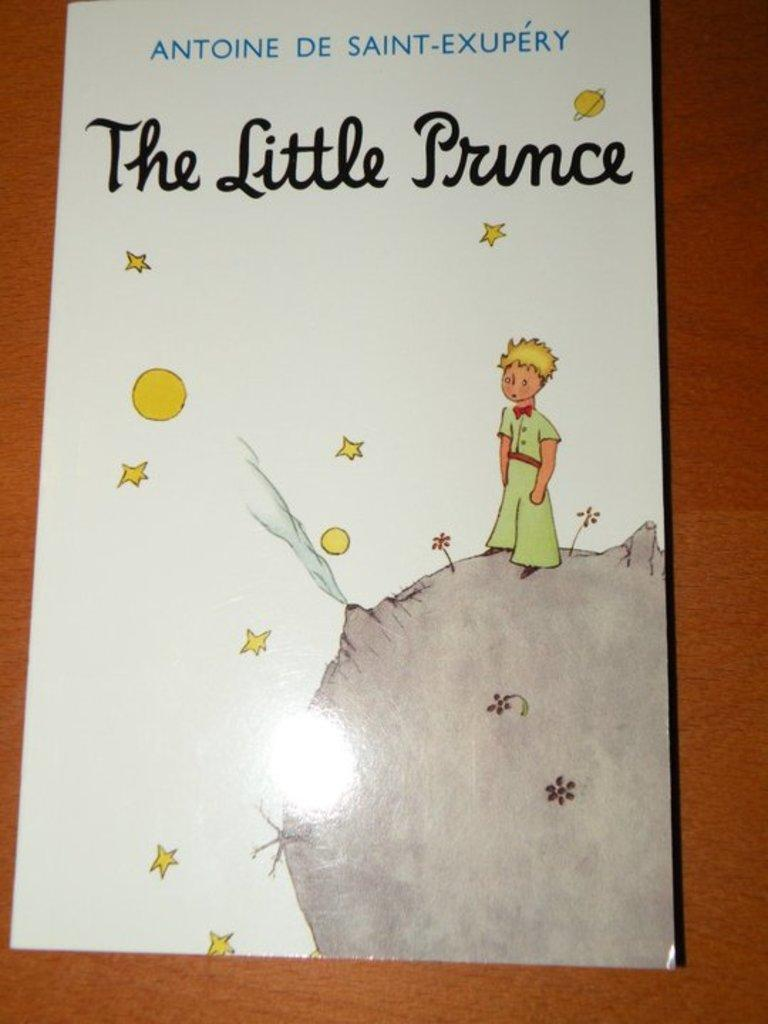<image>
Relay a brief, clear account of the picture shown. A book titled The Little Prince sits on a brown desk. 